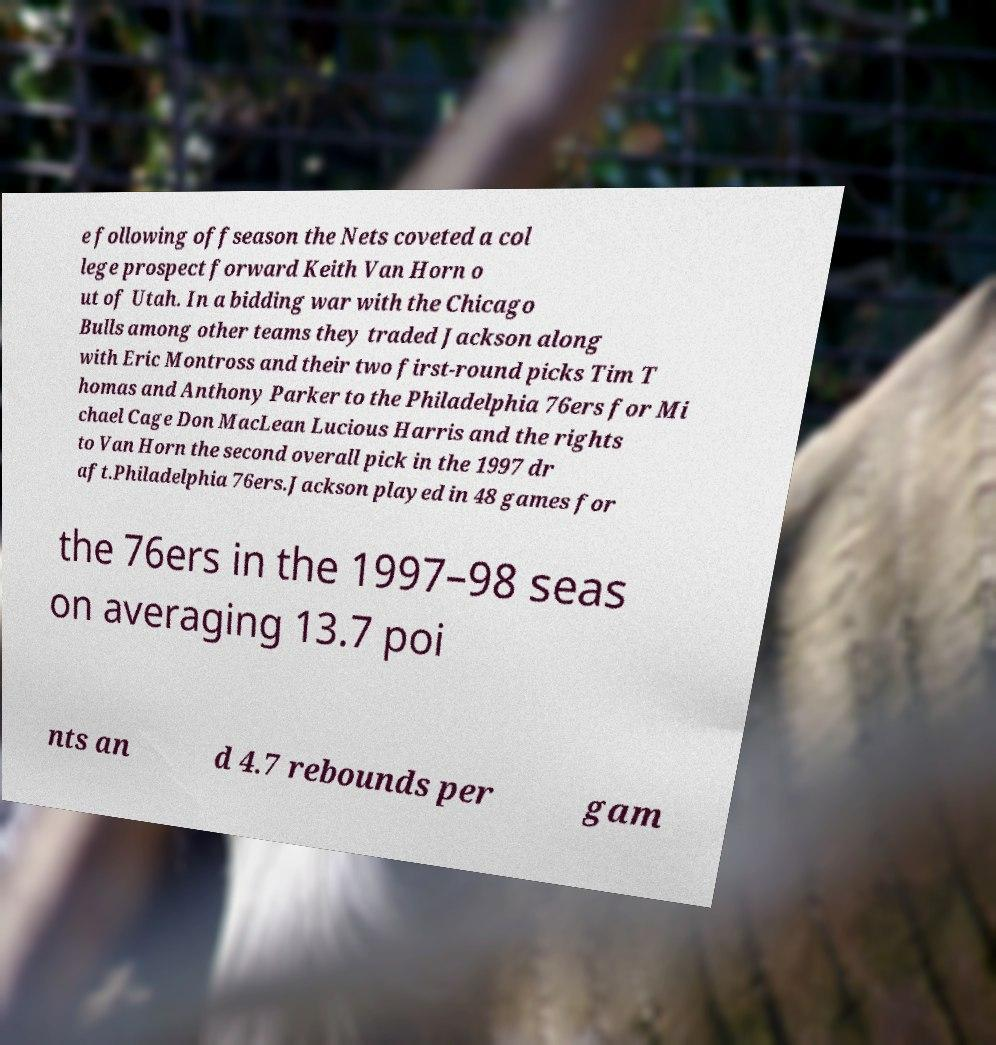Please read and relay the text visible in this image. What does it say? e following offseason the Nets coveted a col lege prospect forward Keith Van Horn o ut of Utah. In a bidding war with the Chicago Bulls among other teams they traded Jackson along with Eric Montross and their two first-round picks Tim T homas and Anthony Parker to the Philadelphia 76ers for Mi chael Cage Don MacLean Lucious Harris and the rights to Van Horn the second overall pick in the 1997 dr aft.Philadelphia 76ers.Jackson played in 48 games for the 76ers in the 1997–98 seas on averaging 13.7 poi nts an d 4.7 rebounds per gam 